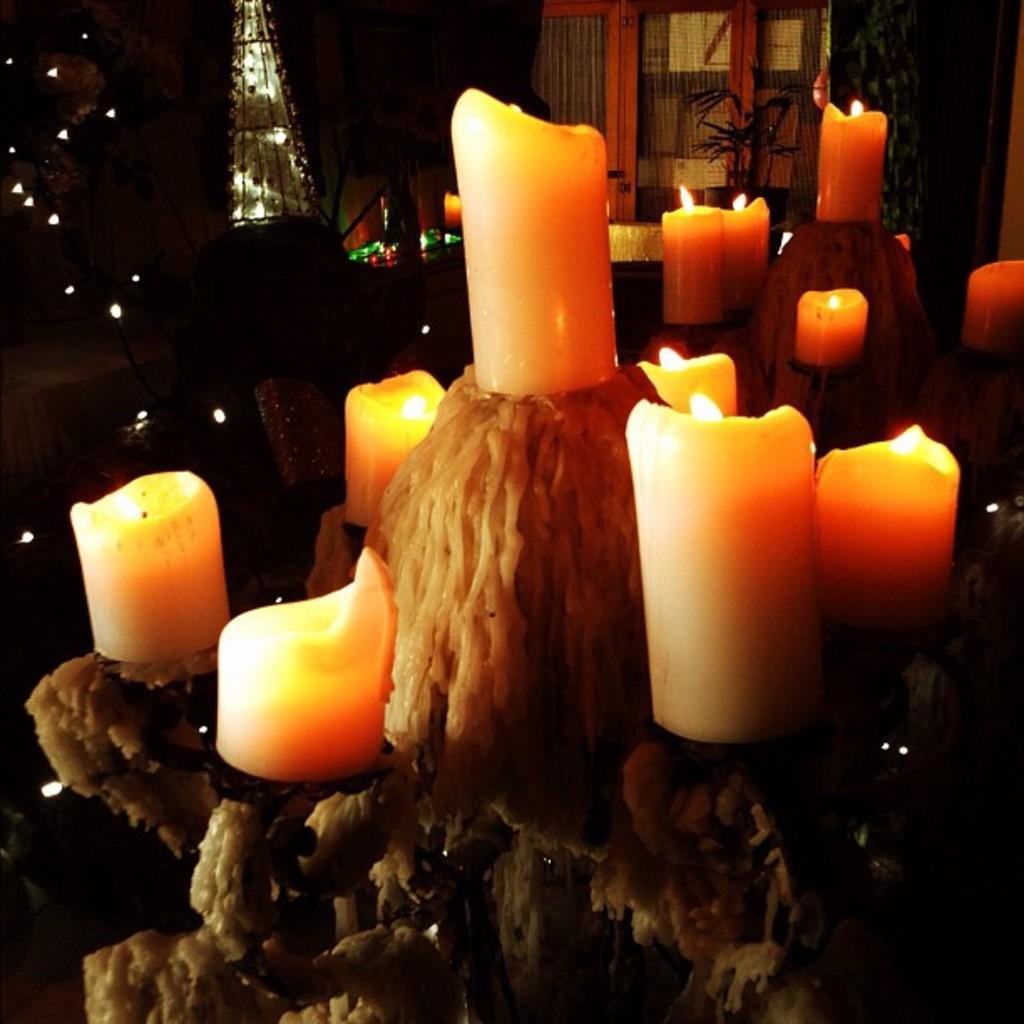How would you summarize this image in a sentence or two? This picture is inside view of a room. We can see lights, window, plant, candles, stand, wall are there. 